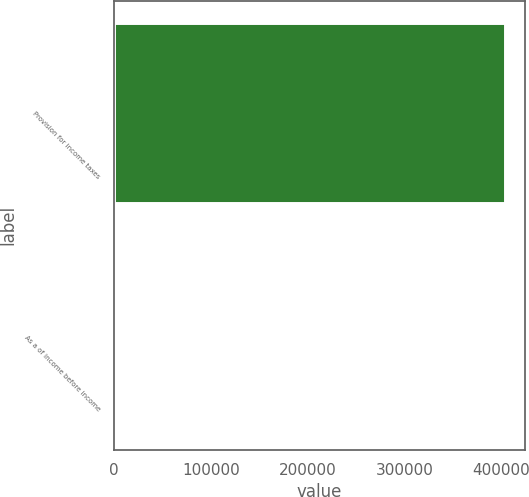Convert chart to OTSL. <chart><loc_0><loc_0><loc_500><loc_500><bar_chart><fcel>Provision for income taxes<fcel>As a of income before income<nl><fcel>404090<fcel>19<nl></chart> 